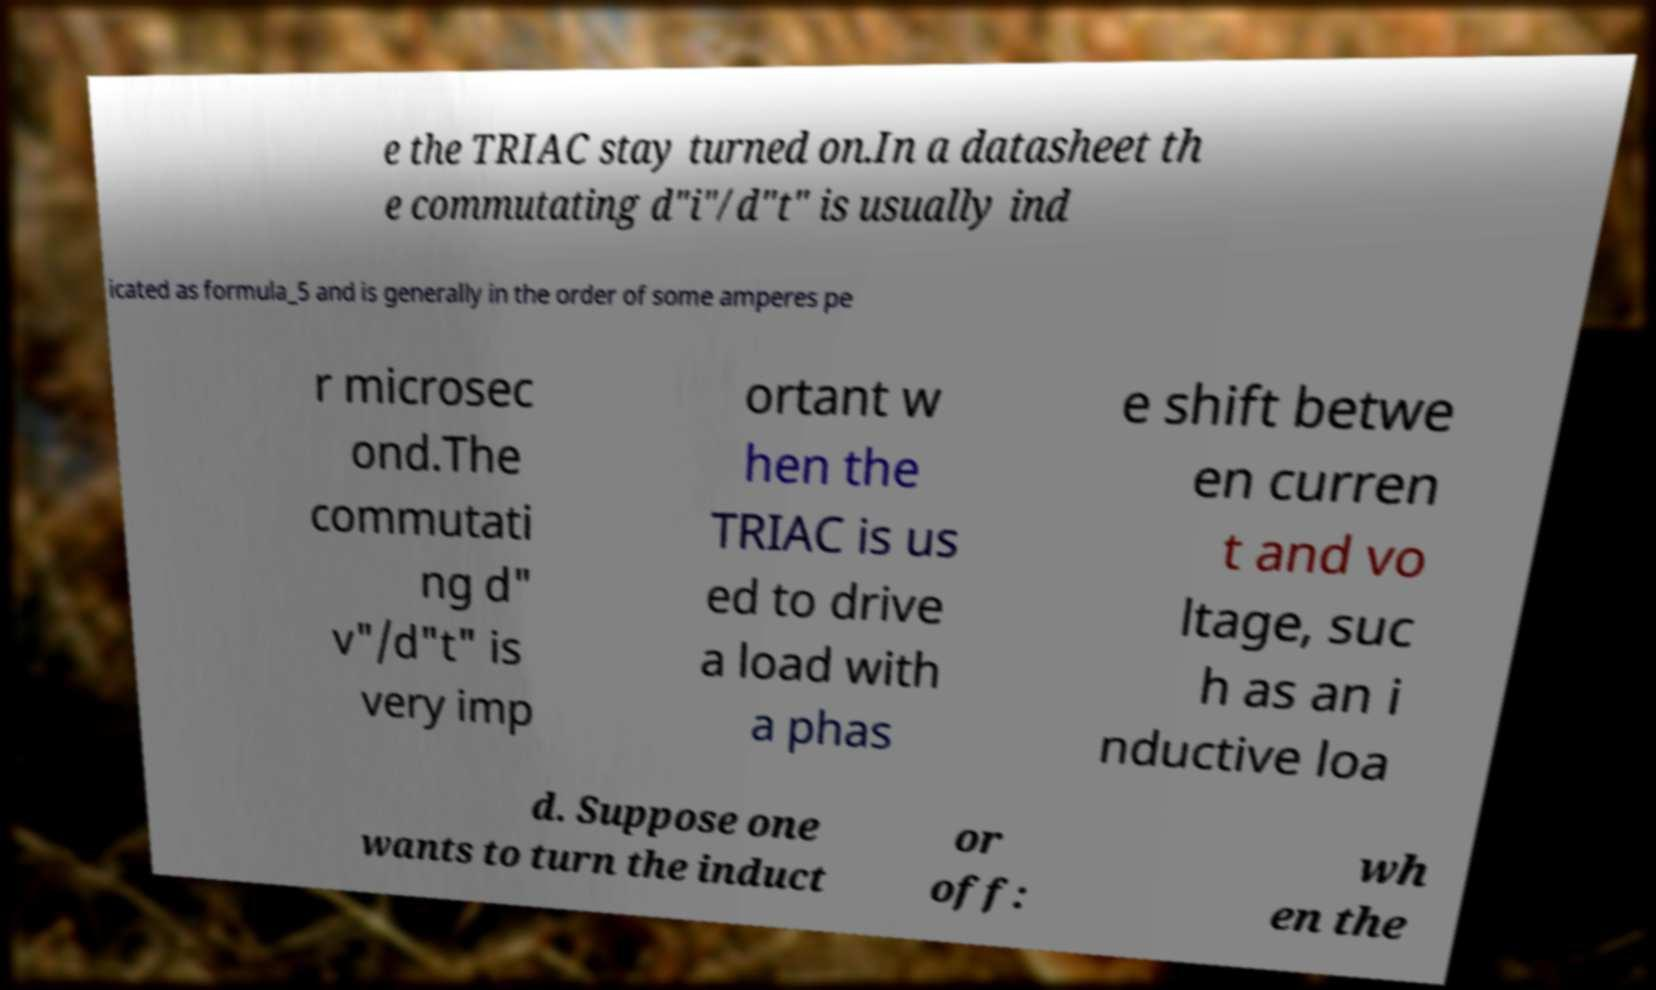Can you read and provide the text displayed in the image?This photo seems to have some interesting text. Can you extract and type it out for me? e the TRIAC stay turned on.In a datasheet th e commutating d"i"/d"t" is usually ind icated as formula_5 and is generally in the order of some amperes pe r microsec ond.The commutati ng d" v"/d"t" is very imp ortant w hen the TRIAC is us ed to drive a load with a phas e shift betwe en curren t and vo ltage, suc h as an i nductive loa d. Suppose one wants to turn the induct or off: wh en the 